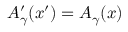Convert formula to latex. <formula><loc_0><loc_0><loc_500><loc_500>A _ { \gamma } ^ { \prime } ( x ^ { \prime } ) = A _ { \gamma } ( x )</formula> 